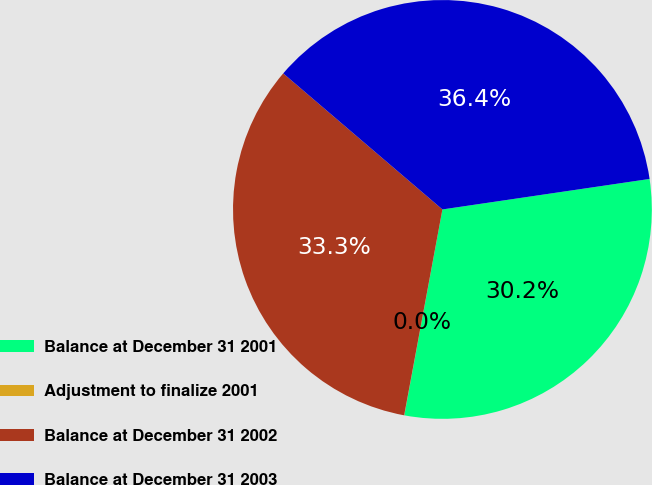<chart> <loc_0><loc_0><loc_500><loc_500><pie_chart><fcel>Balance at December 31 2001<fcel>Adjustment to finalize 2001<fcel>Balance at December 31 2002<fcel>Balance at December 31 2003<nl><fcel>30.24%<fcel>0.01%<fcel>33.33%<fcel>36.42%<nl></chart> 